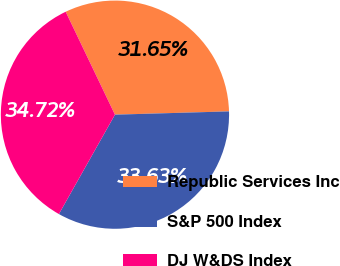Convert chart to OTSL. <chart><loc_0><loc_0><loc_500><loc_500><pie_chart><fcel>Republic Services Inc<fcel>S&P 500 Index<fcel>DJ W&DS Index<nl><fcel>31.65%<fcel>33.63%<fcel>34.72%<nl></chart> 